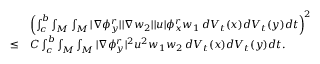<formula> <loc_0><loc_0><loc_500><loc_500>\begin{array} { r l } & { \left ( \int _ { c } ^ { b } \int _ { M } \int _ { M } | \nabla \phi _ { y } ^ { r } | | \nabla w _ { 2 } | | u | \phi _ { x } ^ { r } w _ { 1 } \, d V _ { t } ( x ) d V _ { t } ( y ) d t \right ) ^ { 2 } } \\ { \leq } & { C \int _ { c } ^ { b } \int _ { M } \int _ { M } | \nabla \phi _ { y } ^ { r } | ^ { 2 } u ^ { 2 } w _ { 1 } w _ { 2 } \, d V _ { t } ( x ) d V _ { t } ( y ) d t . } \end{array}</formula> 